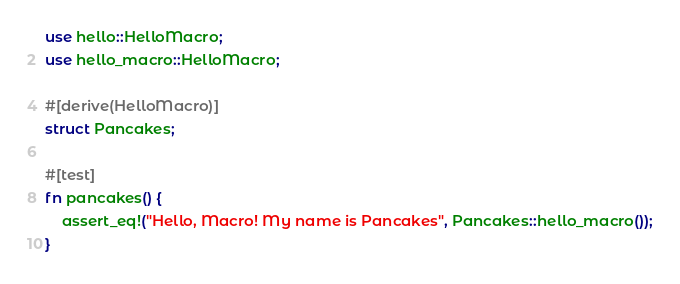Convert code to text. <code><loc_0><loc_0><loc_500><loc_500><_Rust_>use hello::HelloMacro;
use hello_macro::HelloMacro;

#[derive(HelloMacro)]
struct Pancakes;

#[test]
fn pancakes() {
    assert_eq!("Hello, Macro! My name is Pancakes", Pancakes::hello_macro());
}
</code> 